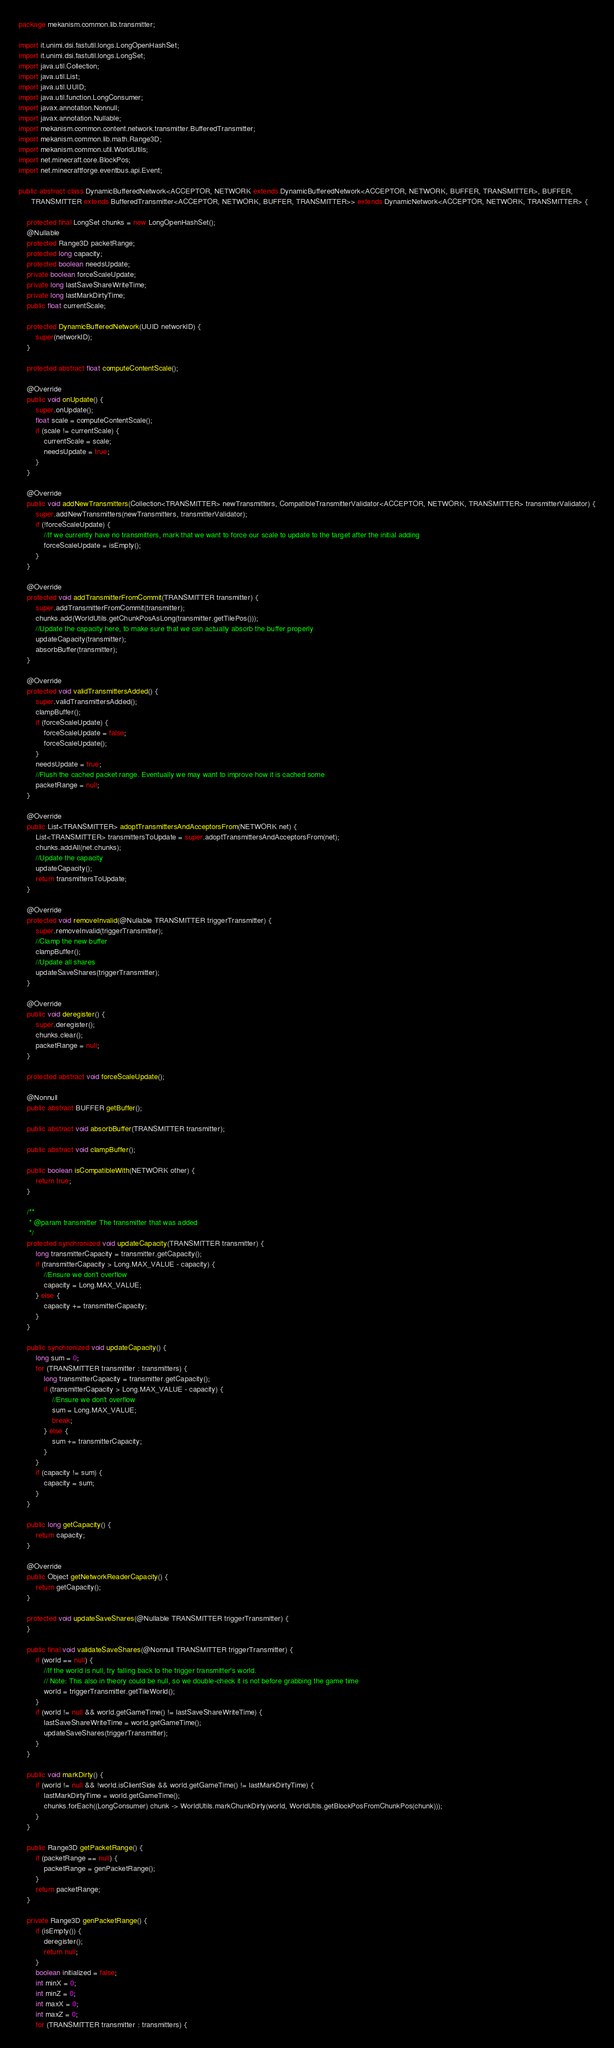<code> <loc_0><loc_0><loc_500><loc_500><_Java_>package mekanism.common.lib.transmitter;

import it.unimi.dsi.fastutil.longs.LongOpenHashSet;
import it.unimi.dsi.fastutil.longs.LongSet;
import java.util.Collection;
import java.util.List;
import java.util.UUID;
import java.util.function.LongConsumer;
import javax.annotation.Nonnull;
import javax.annotation.Nullable;
import mekanism.common.content.network.transmitter.BufferedTransmitter;
import mekanism.common.lib.math.Range3D;
import mekanism.common.util.WorldUtils;
import net.minecraft.core.BlockPos;
import net.minecraftforge.eventbus.api.Event;

public abstract class DynamicBufferedNetwork<ACCEPTOR, NETWORK extends DynamicBufferedNetwork<ACCEPTOR, NETWORK, BUFFER, TRANSMITTER>, BUFFER,
      TRANSMITTER extends BufferedTransmitter<ACCEPTOR, NETWORK, BUFFER, TRANSMITTER>> extends DynamicNetwork<ACCEPTOR, NETWORK, TRANSMITTER> {

    protected final LongSet chunks = new LongOpenHashSet();
    @Nullable
    protected Range3D packetRange;
    protected long capacity;
    protected boolean needsUpdate;
    private boolean forceScaleUpdate;
    private long lastSaveShareWriteTime;
    private long lastMarkDirtyTime;
    public float currentScale;

    protected DynamicBufferedNetwork(UUID networkID) {
        super(networkID);
    }

    protected abstract float computeContentScale();

    @Override
    public void onUpdate() {
        super.onUpdate();
        float scale = computeContentScale();
        if (scale != currentScale) {
            currentScale = scale;
            needsUpdate = true;
        }
    }

    @Override
    public void addNewTransmitters(Collection<TRANSMITTER> newTransmitters, CompatibleTransmitterValidator<ACCEPTOR, NETWORK, TRANSMITTER> transmitterValidator) {
        super.addNewTransmitters(newTransmitters, transmitterValidator);
        if (!forceScaleUpdate) {
            //If we currently have no transmitters, mark that we want to force our scale to update to the target after the initial adding
            forceScaleUpdate = isEmpty();
        }
    }

    @Override
    protected void addTransmitterFromCommit(TRANSMITTER transmitter) {
        super.addTransmitterFromCommit(transmitter);
        chunks.add(WorldUtils.getChunkPosAsLong(transmitter.getTilePos()));
        //Update the capacity here, to make sure that we can actually absorb the buffer properly
        updateCapacity(transmitter);
        absorbBuffer(transmitter);
    }

    @Override
    protected void validTransmittersAdded() {
        super.validTransmittersAdded();
        clampBuffer();
        if (forceScaleUpdate) {
            forceScaleUpdate = false;
            forceScaleUpdate();
        }
        needsUpdate = true;
        //Flush the cached packet range. Eventually we may want to improve how it is cached some
        packetRange = null;
    }

    @Override
    public List<TRANSMITTER> adoptTransmittersAndAcceptorsFrom(NETWORK net) {
        List<TRANSMITTER> transmittersToUpdate = super.adoptTransmittersAndAcceptorsFrom(net);
        chunks.addAll(net.chunks);
        //Update the capacity
        updateCapacity();
        return transmittersToUpdate;
    }

    @Override
    protected void removeInvalid(@Nullable TRANSMITTER triggerTransmitter) {
        super.removeInvalid(triggerTransmitter);
        //Clamp the new buffer
        clampBuffer();
        //Update all shares
        updateSaveShares(triggerTransmitter);
    }

    @Override
    public void deregister() {
        super.deregister();
        chunks.clear();
        packetRange = null;
    }

    protected abstract void forceScaleUpdate();

    @Nonnull
    public abstract BUFFER getBuffer();

    public abstract void absorbBuffer(TRANSMITTER transmitter);

    public abstract void clampBuffer();

    public boolean isCompatibleWith(NETWORK other) {
        return true;
    }

    /**
     * @param transmitter The transmitter that was added
     */
    protected synchronized void updateCapacity(TRANSMITTER transmitter) {
        long transmitterCapacity = transmitter.getCapacity();
        if (transmitterCapacity > Long.MAX_VALUE - capacity) {
            //Ensure we don't overflow
            capacity = Long.MAX_VALUE;
        } else {
            capacity += transmitterCapacity;
        }
    }

    public synchronized void updateCapacity() {
        long sum = 0;
        for (TRANSMITTER transmitter : transmitters) {
            long transmitterCapacity = transmitter.getCapacity();
            if (transmitterCapacity > Long.MAX_VALUE - capacity) {
                //Ensure we don't overflow
                sum = Long.MAX_VALUE;
                break;
            } else {
                sum += transmitterCapacity;
            }
        }
        if (capacity != sum) {
            capacity = sum;
        }
    }

    public long getCapacity() {
        return capacity;
    }

    @Override
    public Object getNetworkReaderCapacity() {
        return getCapacity();
    }

    protected void updateSaveShares(@Nullable TRANSMITTER triggerTransmitter) {
    }

    public final void validateSaveShares(@Nonnull TRANSMITTER triggerTransmitter) {
        if (world == null) {
            //If the world is null, try falling back to the trigger transmitter's world.
            // Note: This also in theory could be null, so we double-check it is not before grabbing the game time
            world = triggerTransmitter.getTileWorld();
        }
        if (world != null && world.getGameTime() != lastSaveShareWriteTime) {
            lastSaveShareWriteTime = world.getGameTime();
            updateSaveShares(triggerTransmitter);
        }
    }

    public void markDirty() {
        if (world != null && !world.isClientSide && world.getGameTime() != lastMarkDirtyTime) {
            lastMarkDirtyTime = world.getGameTime();
            chunks.forEach((LongConsumer) chunk -> WorldUtils.markChunkDirty(world, WorldUtils.getBlockPosFromChunkPos(chunk)));
        }
    }

    public Range3D getPacketRange() {
        if (packetRange == null) {
            packetRange = genPacketRange();
        }
        return packetRange;
    }

    private Range3D genPacketRange() {
        if (isEmpty()) {
            deregister();
            return null;
        }
        boolean initialized = false;
        int minX = 0;
        int minZ = 0;
        int maxX = 0;
        int maxZ = 0;
        for (TRANSMITTER transmitter : transmitters) {</code> 